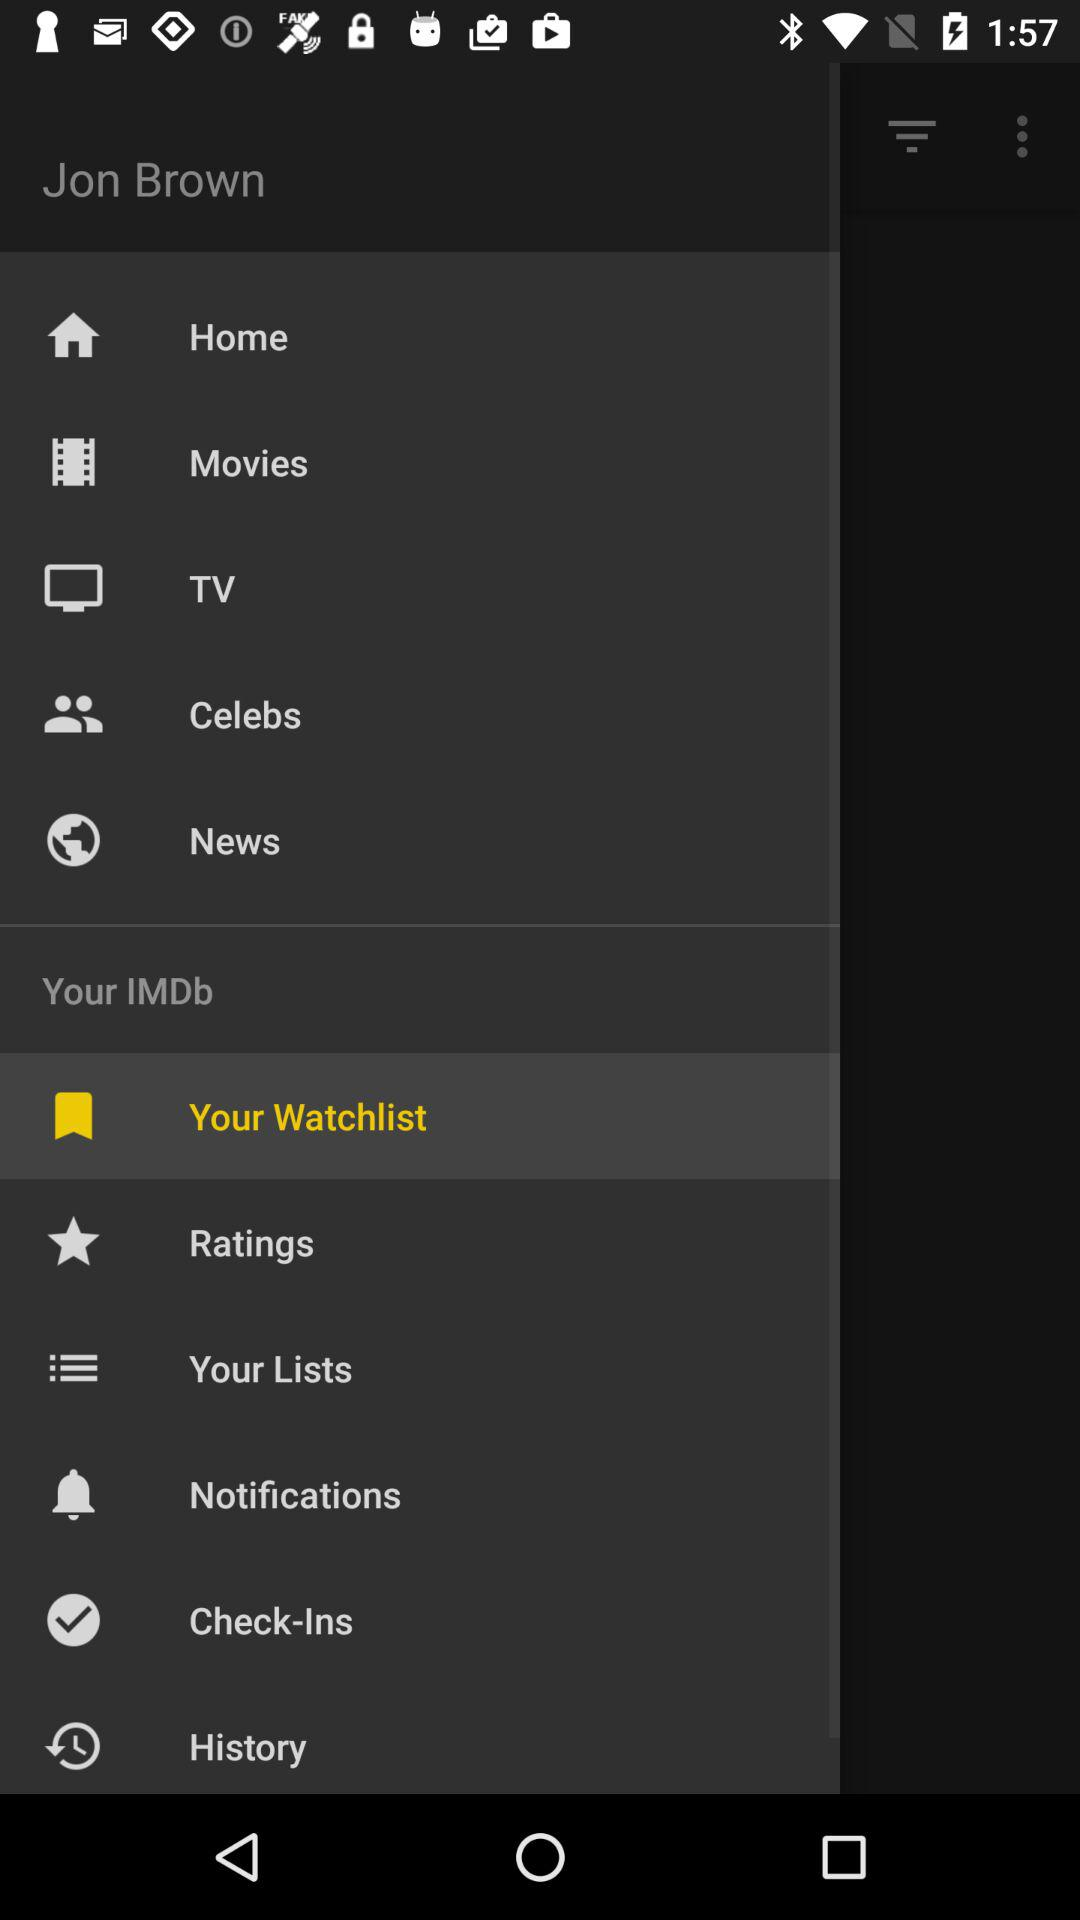Which item is selected? The selected item is "Your Watchlist". 